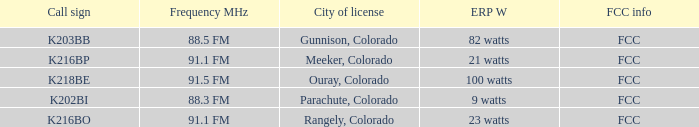Which FCC info has an ERP W of 100 watts? FCC. 